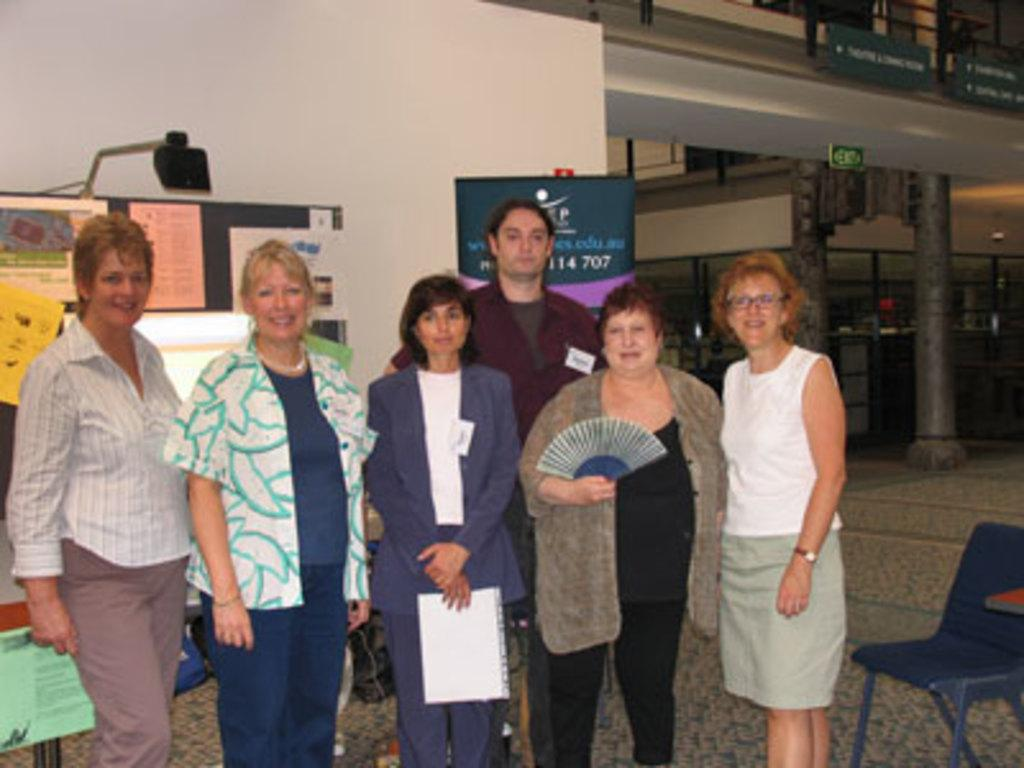What are the people in the image doing? The group of people is standing on the floor. What can be seen on the right side of the image? There is a chair on the right side of the image. What object is present in the image that might be used for displaying information or writing? There is a board in the image. What type of background is visible in the image? There is a white wall in the image. What type of jam is being spread on the beds in the image? There are no beds or jam present in the image. 